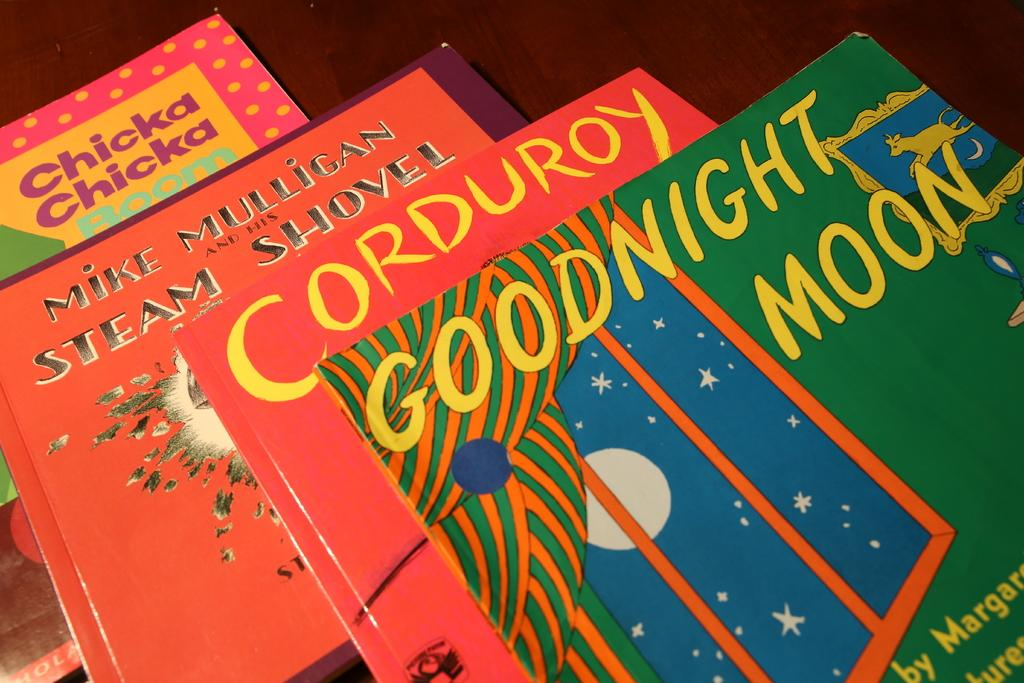<image>
Create a compact narrative representing the image presented. A pile of books with the top being called Goodnight Moon 